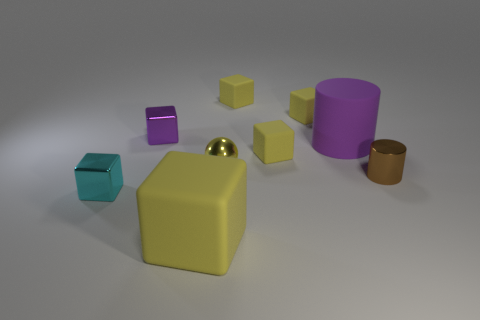There is a big object that is in front of the large thing to the right of the small yellow metal ball; what is it made of?
Your answer should be compact. Rubber. There is a tiny thing that is on the left side of the tiny metallic object that is behind the sphere that is behind the brown metallic object; what is its shape?
Provide a succinct answer. Cube. Does the big rubber thing that is in front of the brown object have the same shape as the purple object that is on the right side of the sphere?
Make the answer very short. No. What number of other objects are there of the same material as the large cube?
Provide a succinct answer. 4. What is the shape of the small brown thing that is made of the same material as the small sphere?
Provide a short and direct response. Cylinder. Is the size of the brown metal cylinder the same as the purple matte cylinder?
Provide a succinct answer. No. There is a thing in front of the small object that is in front of the brown metal cylinder; what size is it?
Ensure brevity in your answer.  Large. What is the shape of the shiny thing that is the same color as the big block?
Provide a short and direct response. Sphere. What number of blocks are large things or small brown things?
Give a very brief answer. 1. There is a purple rubber object; is its size the same as the cylinder in front of the yellow metallic ball?
Provide a short and direct response. No. 